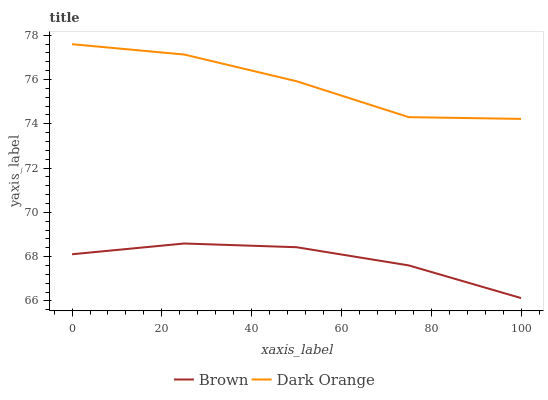Does Brown have the minimum area under the curve?
Answer yes or no. Yes. Does Dark Orange have the maximum area under the curve?
Answer yes or no. Yes. Does Dark Orange have the minimum area under the curve?
Answer yes or no. No. Is Brown the smoothest?
Answer yes or no. Yes. Is Dark Orange the roughest?
Answer yes or no. Yes. Is Dark Orange the smoothest?
Answer yes or no. No. Does Brown have the lowest value?
Answer yes or no. Yes. Does Dark Orange have the lowest value?
Answer yes or no. No. Does Dark Orange have the highest value?
Answer yes or no. Yes. Is Brown less than Dark Orange?
Answer yes or no. Yes. Is Dark Orange greater than Brown?
Answer yes or no. Yes. Does Brown intersect Dark Orange?
Answer yes or no. No. 